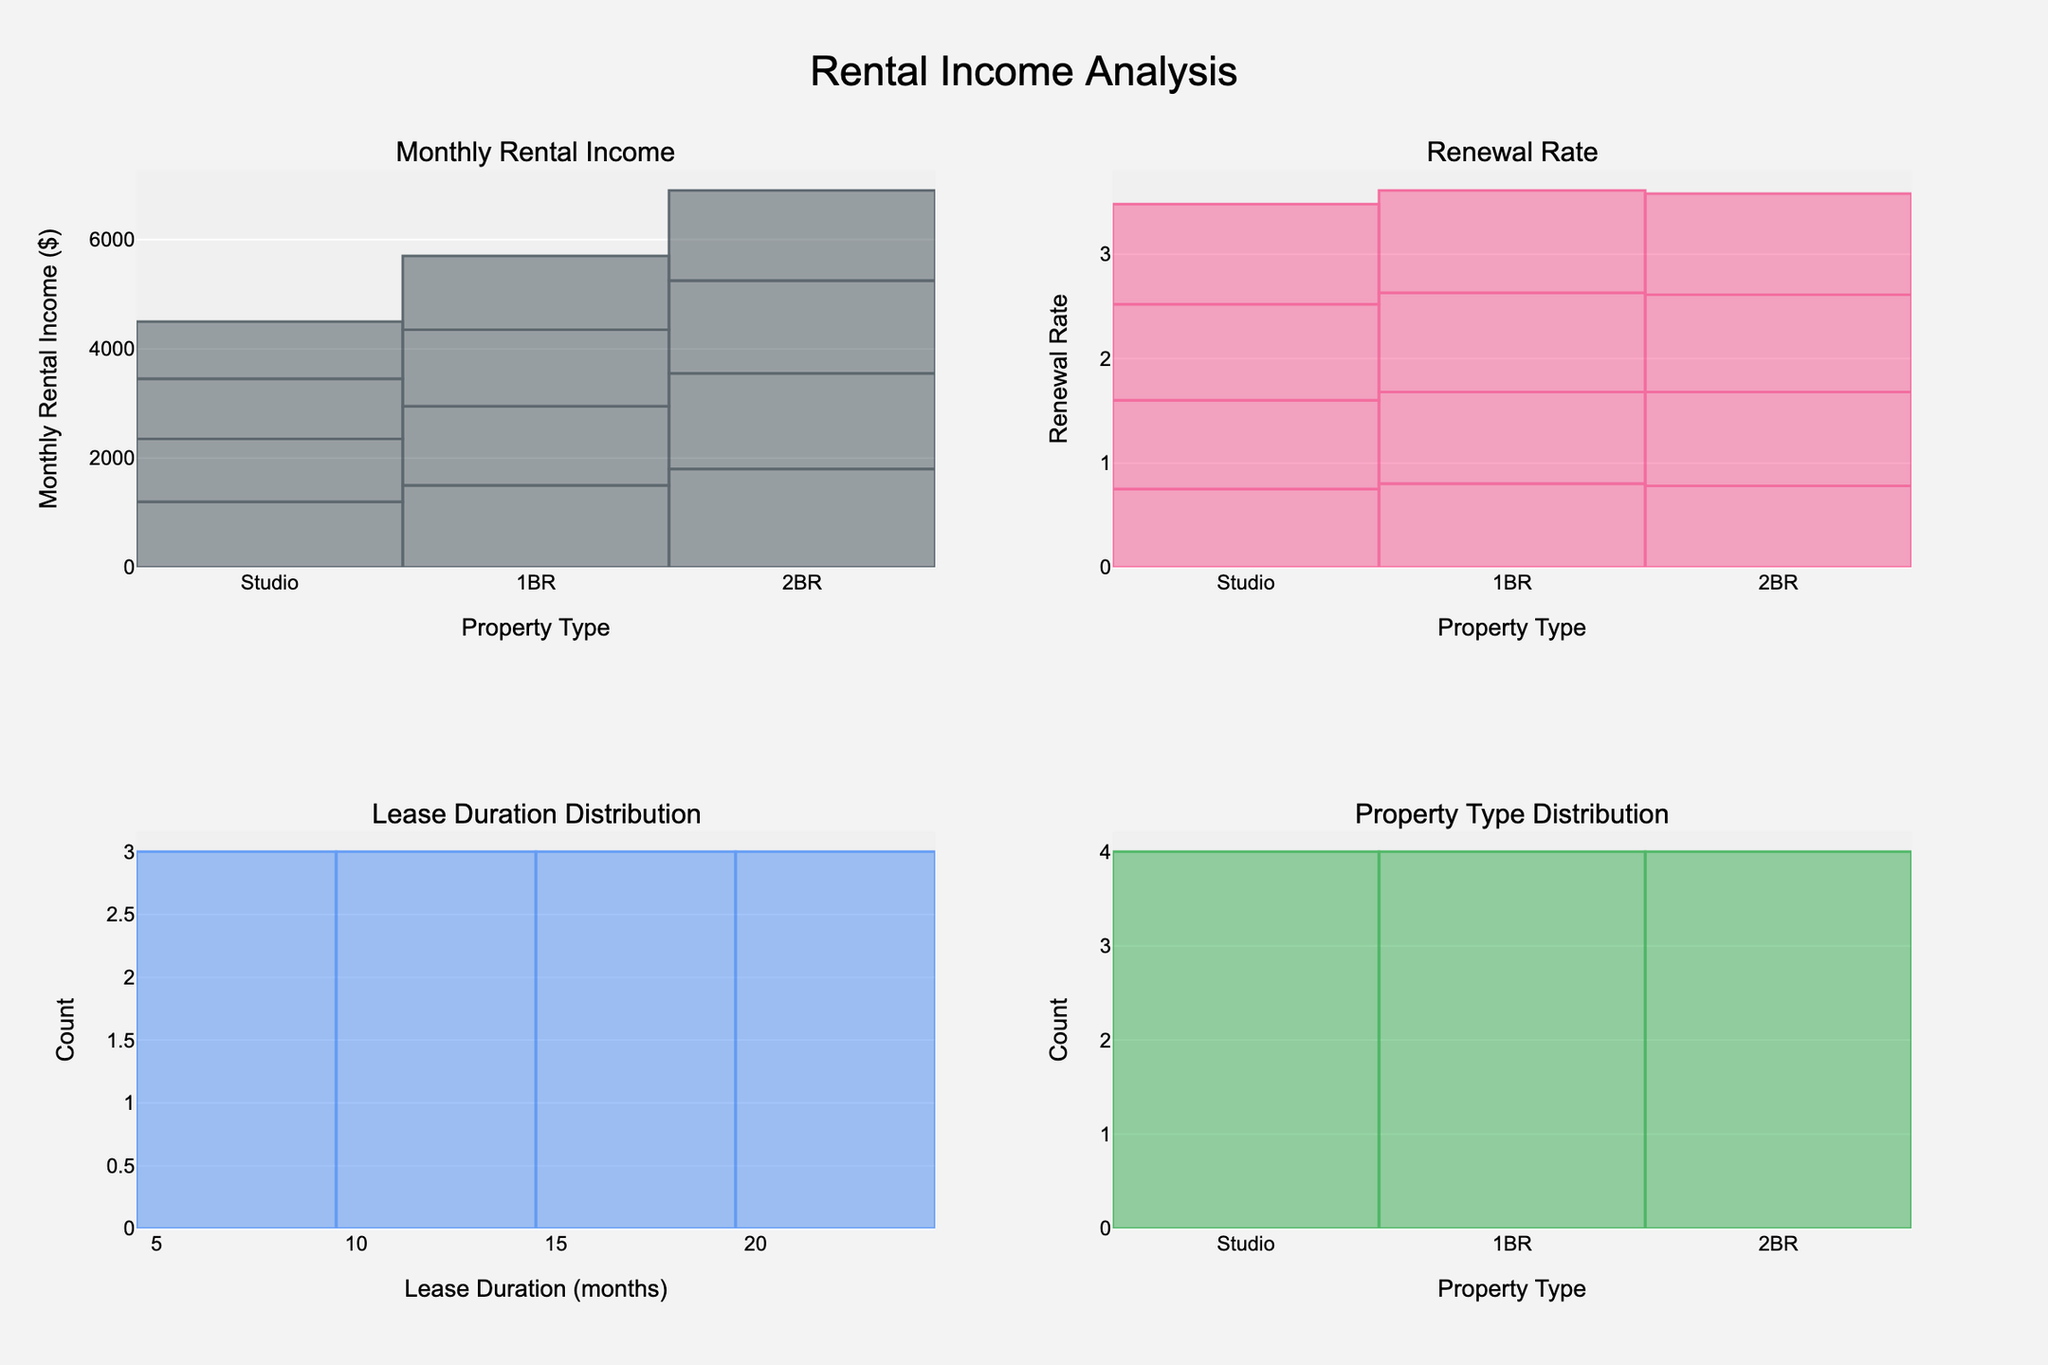What is the title of the figure? The title of the figure is usually displayed at the top of the plot. In this case, the title is "Rental Income Analysis".
Answer: Rental Income Analysis Which property type has the highest monthly rental income? By looking at the first subplot "Monthly Rental Income", we can see the heights of the bars for different property types. The highest bar is for the "2BR" property type.
Answer: 2BR Which property type has the highest renewal rate? By examining the second subplot "Renewal Rate", the heights of the bars for different property types show that the renewal rate is highest for "1BR".
Answer: 1BR What is the most common lease duration? From the "Lease Duration Distribution" subplot, the tallest bar indicates the most common (or most frequent) lease duration. In this case, the most common lease duration is 24 months.
Answer: 24 months Which property type has the lowest monthly rental income? By checking the first subplot "Monthly Rental Income", the shortest bar is indicative of the lowest monthly rental income. "Studio" has the lowest rental income.
Answer: Studio What is the difference in monthly rental income between 6-month and 24-month leases for 1BR properties? Looking at the first subplot, find the monthly rental income for 1BR for 6-month (1500) and 24-month (1350) leases. Subtract the smaller value from the larger value: 1500 - 1350 = 150.
Answer: 150 Which lease duration has the highest count in the "Lease Duration Distribution" subplot? The "Lease Duration Distribution" subplot shows a count of data points for each lease duration. The bar representing 24 months is the tallest, indicating the highest count.
Answer: 24 months What is the average renewal rate of Studio apartments across different lease durations? To find this average, add the renewal rates for Studio (0.75, 0.85, 0.92, 0.96) and divide by the number of entries. Hence, (0.75 + 0.85 + 0.92 + 0.96) / 4 = 0.87.
Answer: 0.87 Is there a trend in renewal rates as lease durations increase for 2BR properties? By analyzing the renewal rates for 2BR properties across different lease durations in the "Renewal Rate" subplot, there is an increasing trend. Renewal rates go from 0.78 to 0.90 to 0.93 to 0.97 as lease durations increase.
Answer: Yes If you want to maximize monthly rental income, which lease duration should you prioritize for Studio apartments? From the "Monthly Rental Income" subplot, the 6-month lease duration has the highest bar for Studio apartments with an income of 1200.
Answer: 6 months 